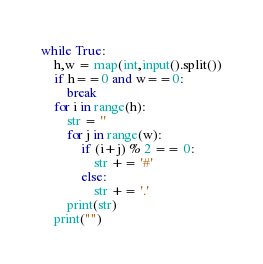Convert code to text. <code><loc_0><loc_0><loc_500><loc_500><_Python_>while True:
    h,w = map(int,input().split())
    if h==0 and w==0:
        break
    for i in range(h):
        str = ''
        for j in range(w):
            if (i+j) % 2 == 0:
                str += '#'
            else:
                str += '.'
        print(str)
    print("")
</code> 